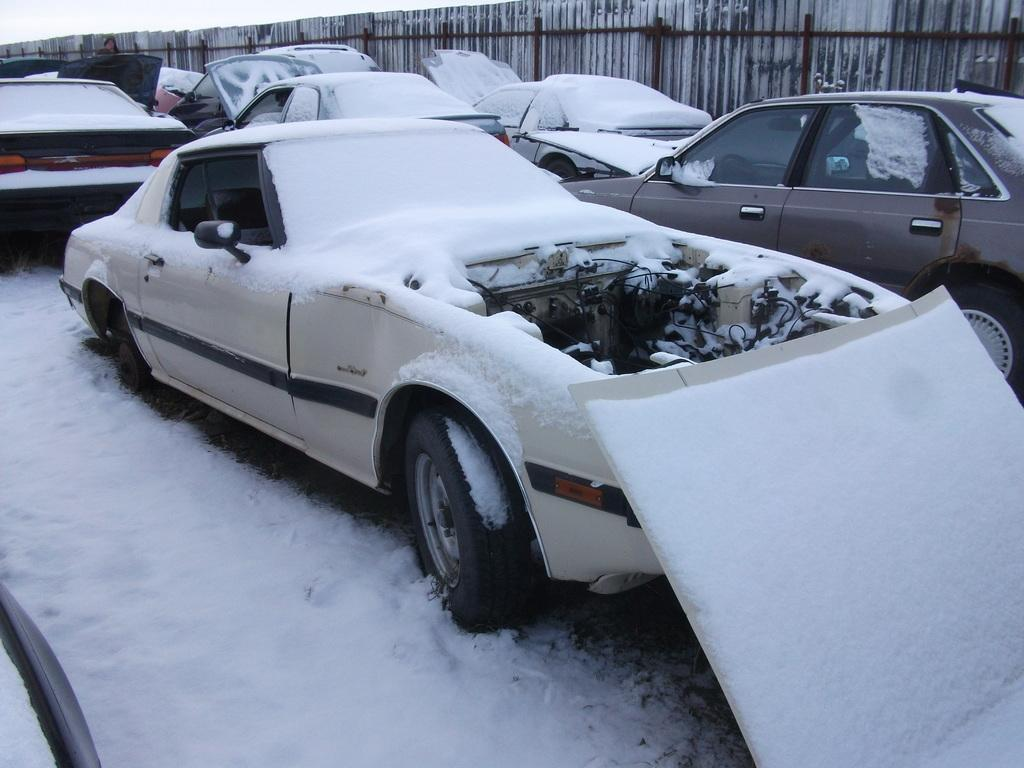What can be seen in the image? There are vehicles in the image. How are some of the vehicles affected by the weather? Some vehicles are covered with snow. What is the purpose of the fence visible in the image? The purpose of the fence is not explicitly stated, but it could be used for enclosing an area or providing a barrier. What type of cork is used to seal the juice bottles in the image? There are no juice bottles or corks present in the image. 